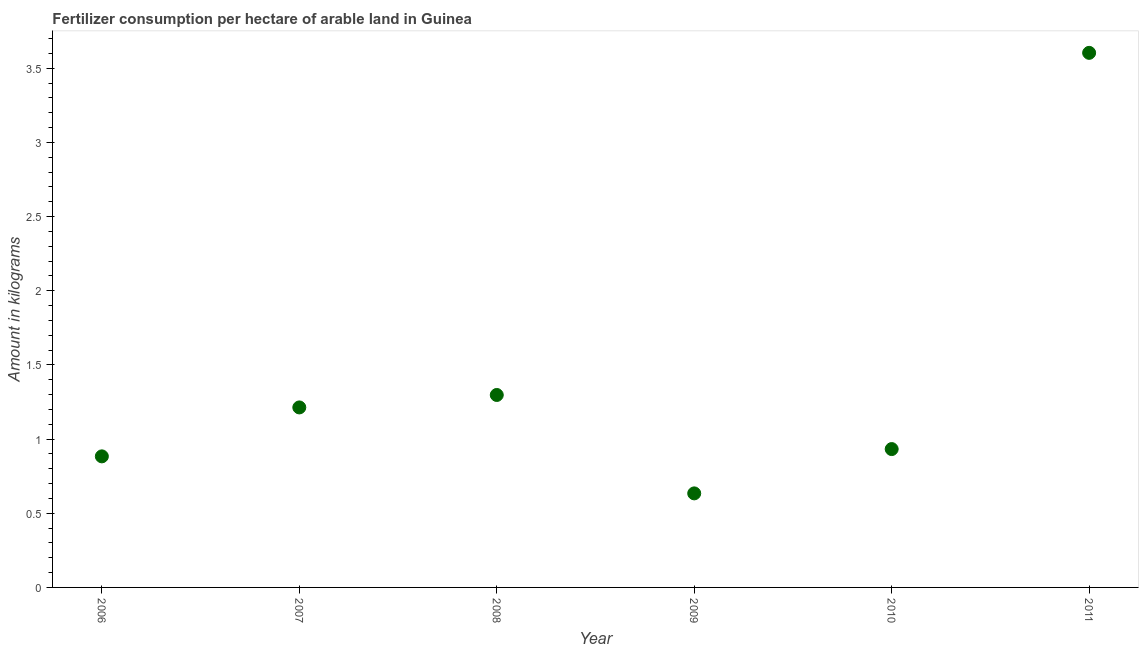What is the amount of fertilizer consumption in 2010?
Provide a succinct answer. 0.93. Across all years, what is the maximum amount of fertilizer consumption?
Ensure brevity in your answer.  3.6. Across all years, what is the minimum amount of fertilizer consumption?
Your response must be concise. 0.63. What is the sum of the amount of fertilizer consumption?
Give a very brief answer. 8.57. What is the difference between the amount of fertilizer consumption in 2008 and 2009?
Your answer should be compact. 0.66. What is the average amount of fertilizer consumption per year?
Offer a very short reply. 1.43. What is the median amount of fertilizer consumption?
Offer a very short reply. 1.07. Do a majority of the years between 2006 and 2007 (inclusive) have amount of fertilizer consumption greater than 0.8 kg?
Your response must be concise. Yes. What is the ratio of the amount of fertilizer consumption in 2008 to that in 2009?
Your response must be concise. 2.05. What is the difference between the highest and the second highest amount of fertilizer consumption?
Your answer should be very brief. 2.31. Is the sum of the amount of fertilizer consumption in 2008 and 2009 greater than the maximum amount of fertilizer consumption across all years?
Offer a terse response. No. What is the difference between the highest and the lowest amount of fertilizer consumption?
Provide a succinct answer. 2.97. How many dotlines are there?
Your response must be concise. 1. Does the graph contain any zero values?
Ensure brevity in your answer.  No. Does the graph contain grids?
Ensure brevity in your answer.  No. What is the title of the graph?
Give a very brief answer. Fertilizer consumption per hectare of arable land in Guinea . What is the label or title of the Y-axis?
Your answer should be compact. Amount in kilograms. What is the Amount in kilograms in 2006?
Your answer should be very brief. 0.88. What is the Amount in kilograms in 2007?
Your response must be concise. 1.21. What is the Amount in kilograms in 2008?
Your answer should be very brief. 1.3. What is the Amount in kilograms in 2009?
Give a very brief answer. 0.63. What is the Amount in kilograms in 2010?
Provide a short and direct response. 0.93. What is the Amount in kilograms in 2011?
Make the answer very short. 3.6. What is the difference between the Amount in kilograms in 2006 and 2007?
Your response must be concise. -0.33. What is the difference between the Amount in kilograms in 2006 and 2008?
Offer a terse response. -0.41. What is the difference between the Amount in kilograms in 2006 and 2009?
Provide a short and direct response. 0.25. What is the difference between the Amount in kilograms in 2006 and 2010?
Offer a very short reply. -0.05. What is the difference between the Amount in kilograms in 2006 and 2011?
Your response must be concise. -2.72. What is the difference between the Amount in kilograms in 2007 and 2008?
Your response must be concise. -0.08. What is the difference between the Amount in kilograms in 2007 and 2009?
Your answer should be very brief. 0.58. What is the difference between the Amount in kilograms in 2007 and 2010?
Offer a terse response. 0.28. What is the difference between the Amount in kilograms in 2007 and 2011?
Your answer should be compact. -2.39. What is the difference between the Amount in kilograms in 2008 and 2009?
Offer a terse response. 0.66. What is the difference between the Amount in kilograms in 2008 and 2010?
Provide a short and direct response. 0.36. What is the difference between the Amount in kilograms in 2008 and 2011?
Offer a terse response. -2.31. What is the difference between the Amount in kilograms in 2009 and 2010?
Offer a terse response. -0.3. What is the difference between the Amount in kilograms in 2009 and 2011?
Give a very brief answer. -2.97. What is the difference between the Amount in kilograms in 2010 and 2011?
Ensure brevity in your answer.  -2.67. What is the ratio of the Amount in kilograms in 2006 to that in 2007?
Your response must be concise. 0.73. What is the ratio of the Amount in kilograms in 2006 to that in 2008?
Your answer should be very brief. 0.68. What is the ratio of the Amount in kilograms in 2006 to that in 2009?
Provide a short and direct response. 1.39. What is the ratio of the Amount in kilograms in 2006 to that in 2010?
Offer a very short reply. 0.95. What is the ratio of the Amount in kilograms in 2006 to that in 2011?
Offer a very short reply. 0.24. What is the ratio of the Amount in kilograms in 2007 to that in 2008?
Keep it short and to the point. 0.94. What is the ratio of the Amount in kilograms in 2007 to that in 2009?
Provide a succinct answer. 1.91. What is the ratio of the Amount in kilograms in 2007 to that in 2010?
Your answer should be compact. 1.3. What is the ratio of the Amount in kilograms in 2007 to that in 2011?
Your answer should be very brief. 0.34. What is the ratio of the Amount in kilograms in 2008 to that in 2009?
Your answer should be compact. 2.05. What is the ratio of the Amount in kilograms in 2008 to that in 2010?
Your answer should be very brief. 1.39. What is the ratio of the Amount in kilograms in 2008 to that in 2011?
Give a very brief answer. 0.36. What is the ratio of the Amount in kilograms in 2009 to that in 2010?
Provide a short and direct response. 0.68. What is the ratio of the Amount in kilograms in 2009 to that in 2011?
Your answer should be compact. 0.18. What is the ratio of the Amount in kilograms in 2010 to that in 2011?
Keep it short and to the point. 0.26. 